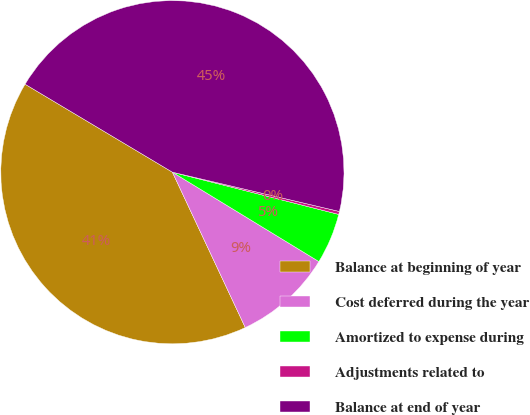Convert chart. <chart><loc_0><loc_0><loc_500><loc_500><pie_chart><fcel>Balance at beginning of year<fcel>Cost deferred during the year<fcel>Amortized to expense during<fcel>Adjustments related to<fcel>Balance at end of year<nl><fcel>40.55%<fcel>9.3%<fcel>4.76%<fcel>0.28%<fcel>45.11%<nl></chart> 